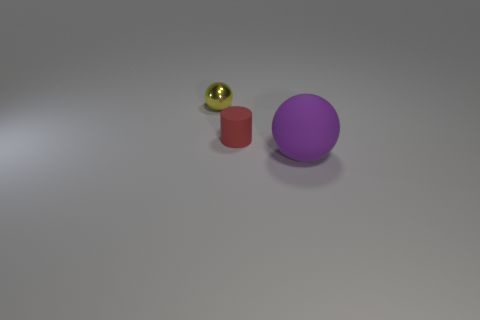Does the matte object that is left of the purple rubber thing have the same size as the small metal thing?
Offer a very short reply. Yes. There is a big purple matte sphere; how many metallic objects are behind it?
Offer a terse response. 1. Are there fewer large purple objects in front of the large purple ball than large purple rubber balls on the right side of the small rubber cylinder?
Your answer should be very brief. Yes. How many small yellow metal cubes are there?
Your answer should be compact. 0. What is the color of the thing that is right of the red object?
Ensure brevity in your answer.  Purple. What is the size of the shiny sphere?
Provide a short and direct response. Small. There is a ball to the right of the ball that is behind the tiny cylinder; what color is it?
Your answer should be compact. Purple. Are there any other things that are the same size as the purple sphere?
Your answer should be compact. No. Does the small object to the left of the tiny red thing have the same shape as the big purple object?
Provide a short and direct response. Yes. How many spheres are both to the right of the small yellow thing and behind the big rubber sphere?
Your response must be concise. 0. 